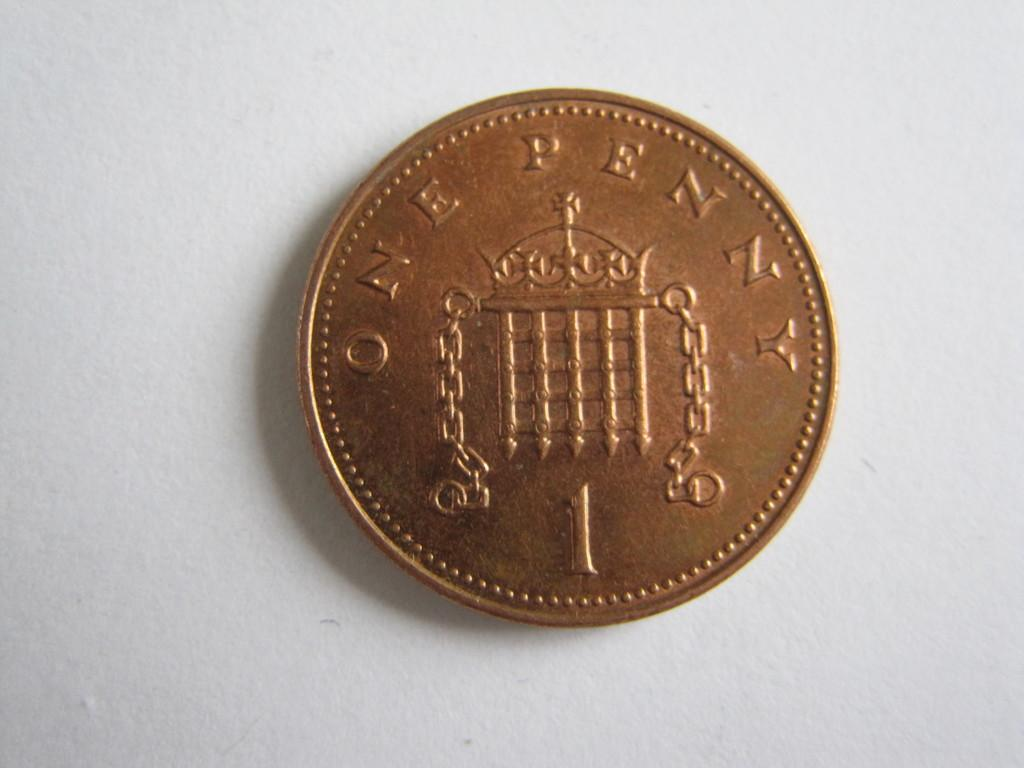Provide a one-sentence caption for the provided image. A copper coin featuring the words ONE PENNY sits on top of a white surface. 